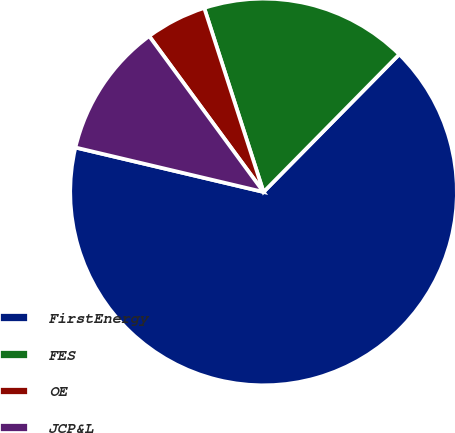Convert chart to OTSL. <chart><loc_0><loc_0><loc_500><loc_500><pie_chart><fcel>FirstEnergy<fcel>FES<fcel>OE<fcel>JCP&L<nl><fcel>66.31%<fcel>17.35%<fcel>5.11%<fcel>11.23%<nl></chart> 